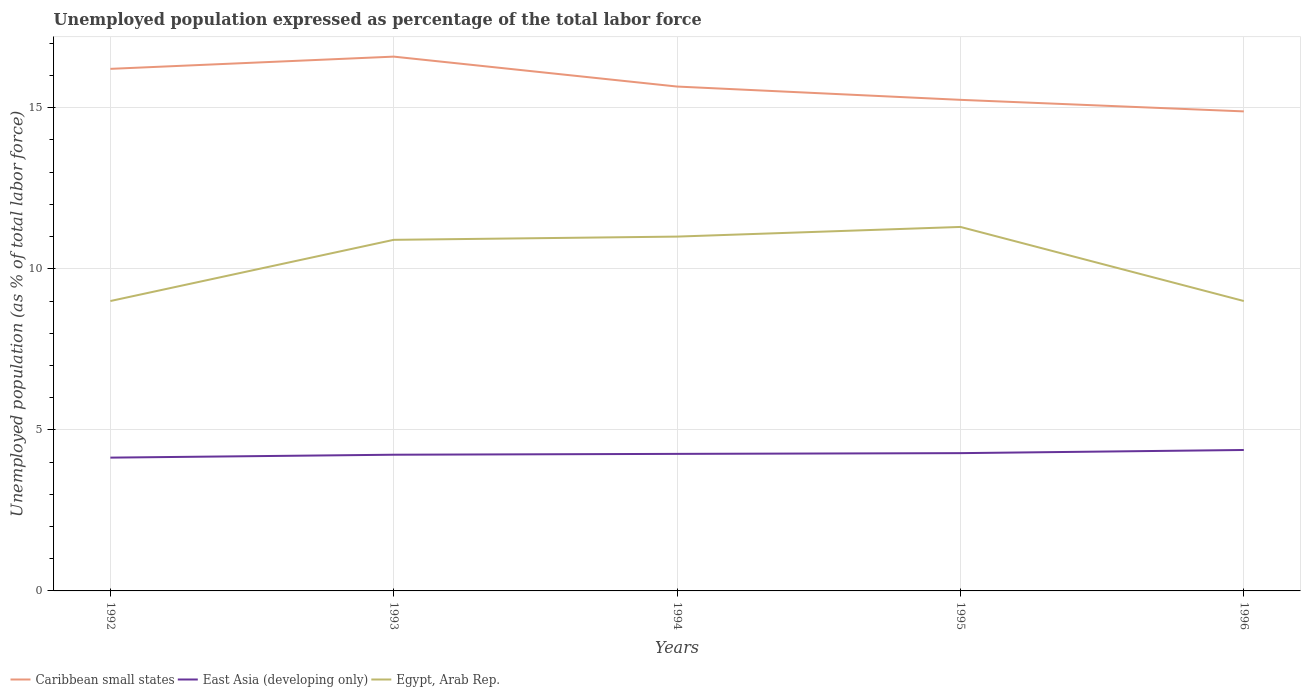Does the line corresponding to Egypt, Arab Rep. intersect with the line corresponding to East Asia (developing only)?
Your response must be concise. No. Across all years, what is the maximum unemployment in in Caribbean small states?
Offer a very short reply. 14.89. What is the difference between the highest and the second highest unemployment in in Egypt, Arab Rep.?
Your answer should be very brief. 2.3. What is the difference between the highest and the lowest unemployment in in Caribbean small states?
Provide a short and direct response. 2. Is the unemployment in in Egypt, Arab Rep. strictly greater than the unemployment in in Caribbean small states over the years?
Your answer should be compact. Yes. How many lines are there?
Offer a very short reply. 3. What is the difference between two consecutive major ticks on the Y-axis?
Make the answer very short. 5. Are the values on the major ticks of Y-axis written in scientific E-notation?
Keep it short and to the point. No. Does the graph contain any zero values?
Provide a succinct answer. No. Does the graph contain grids?
Give a very brief answer. Yes. How are the legend labels stacked?
Offer a terse response. Horizontal. What is the title of the graph?
Provide a short and direct response. Unemployed population expressed as percentage of the total labor force. What is the label or title of the Y-axis?
Offer a terse response. Unemployed population (as % of total labor force). What is the Unemployed population (as % of total labor force) in Caribbean small states in 1992?
Offer a very short reply. 16.21. What is the Unemployed population (as % of total labor force) of East Asia (developing only) in 1992?
Your answer should be compact. 4.14. What is the Unemployed population (as % of total labor force) of Caribbean small states in 1993?
Your response must be concise. 16.59. What is the Unemployed population (as % of total labor force) in East Asia (developing only) in 1993?
Offer a very short reply. 4.23. What is the Unemployed population (as % of total labor force) in Egypt, Arab Rep. in 1993?
Provide a succinct answer. 10.9. What is the Unemployed population (as % of total labor force) of Caribbean small states in 1994?
Make the answer very short. 15.66. What is the Unemployed population (as % of total labor force) in East Asia (developing only) in 1994?
Keep it short and to the point. 4.25. What is the Unemployed population (as % of total labor force) in Caribbean small states in 1995?
Offer a very short reply. 15.25. What is the Unemployed population (as % of total labor force) in East Asia (developing only) in 1995?
Provide a succinct answer. 4.28. What is the Unemployed population (as % of total labor force) of Egypt, Arab Rep. in 1995?
Ensure brevity in your answer.  11.3. What is the Unemployed population (as % of total labor force) in Caribbean small states in 1996?
Your response must be concise. 14.89. What is the Unemployed population (as % of total labor force) in East Asia (developing only) in 1996?
Provide a short and direct response. 4.38. Across all years, what is the maximum Unemployed population (as % of total labor force) of Caribbean small states?
Offer a very short reply. 16.59. Across all years, what is the maximum Unemployed population (as % of total labor force) in East Asia (developing only)?
Offer a very short reply. 4.38. Across all years, what is the maximum Unemployed population (as % of total labor force) in Egypt, Arab Rep.?
Your response must be concise. 11.3. Across all years, what is the minimum Unemployed population (as % of total labor force) in Caribbean small states?
Offer a terse response. 14.89. Across all years, what is the minimum Unemployed population (as % of total labor force) in East Asia (developing only)?
Provide a succinct answer. 4.14. Across all years, what is the minimum Unemployed population (as % of total labor force) in Egypt, Arab Rep.?
Make the answer very short. 9. What is the total Unemployed population (as % of total labor force) in Caribbean small states in the graph?
Offer a very short reply. 78.59. What is the total Unemployed population (as % of total labor force) of East Asia (developing only) in the graph?
Keep it short and to the point. 21.27. What is the total Unemployed population (as % of total labor force) of Egypt, Arab Rep. in the graph?
Provide a succinct answer. 51.2. What is the difference between the Unemployed population (as % of total labor force) in Caribbean small states in 1992 and that in 1993?
Offer a terse response. -0.38. What is the difference between the Unemployed population (as % of total labor force) of East Asia (developing only) in 1992 and that in 1993?
Your response must be concise. -0.09. What is the difference between the Unemployed population (as % of total labor force) of Egypt, Arab Rep. in 1992 and that in 1993?
Your answer should be compact. -1.9. What is the difference between the Unemployed population (as % of total labor force) of Caribbean small states in 1992 and that in 1994?
Your response must be concise. 0.55. What is the difference between the Unemployed population (as % of total labor force) of East Asia (developing only) in 1992 and that in 1994?
Provide a succinct answer. -0.12. What is the difference between the Unemployed population (as % of total labor force) of Egypt, Arab Rep. in 1992 and that in 1994?
Give a very brief answer. -2. What is the difference between the Unemployed population (as % of total labor force) in Caribbean small states in 1992 and that in 1995?
Your answer should be very brief. 0.96. What is the difference between the Unemployed population (as % of total labor force) in East Asia (developing only) in 1992 and that in 1995?
Give a very brief answer. -0.14. What is the difference between the Unemployed population (as % of total labor force) in Egypt, Arab Rep. in 1992 and that in 1995?
Keep it short and to the point. -2.3. What is the difference between the Unemployed population (as % of total labor force) of Caribbean small states in 1992 and that in 1996?
Make the answer very short. 1.32. What is the difference between the Unemployed population (as % of total labor force) in East Asia (developing only) in 1992 and that in 1996?
Offer a very short reply. -0.24. What is the difference between the Unemployed population (as % of total labor force) of Egypt, Arab Rep. in 1992 and that in 1996?
Your answer should be very brief. 0. What is the difference between the Unemployed population (as % of total labor force) of Caribbean small states in 1993 and that in 1994?
Your answer should be very brief. 0.93. What is the difference between the Unemployed population (as % of total labor force) in East Asia (developing only) in 1993 and that in 1994?
Your answer should be very brief. -0.03. What is the difference between the Unemployed population (as % of total labor force) of Egypt, Arab Rep. in 1993 and that in 1994?
Your answer should be compact. -0.1. What is the difference between the Unemployed population (as % of total labor force) of Caribbean small states in 1993 and that in 1995?
Ensure brevity in your answer.  1.34. What is the difference between the Unemployed population (as % of total labor force) in East Asia (developing only) in 1993 and that in 1995?
Provide a short and direct response. -0.05. What is the difference between the Unemployed population (as % of total labor force) of Egypt, Arab Rep. in 1993 and that in 1995?
Provide a short and direct response. -0.4. What is the difference between the Unemployed population (as % of total labor force) in Caribbean small states in 1993 and that in 1996?
Make the answer very short. 1.7. What is the difference between the Unemployed population (as % of total labor force) of East Asia (developing only) in 1993 and that in 1996?
Provide a succinct answer. -0.15. What is the difference between the Unemployed population (as % of total labor force) of Egypt, Arab Rep. in 1993 and that in 1996?
Your response must be concise. 1.9. What is the difference between the Unemployed population (as % of total labor force) in Caribbean small states in 1994 and that in 1995?
Offer a very short reply. 0.41. What is the difference between the Unemployed population (as % of total labor force) of East Asia (developing only) in 1994 and that in 1995?
Provide a succinct answer. -0.02. What is the difference between the Unemployed population (as % of total labor force) in Egypt, Arab Rep. in 1994 and that in 1995?
Offer a terse response. -0.3. What is the difference between the Unemployed population (as % of total labor force) of Caribbean small states in 1994 and that in 1996?
Offer a terse response. 0.77. What is the difference between the Unemployed population (as % of total labor force) of East Asia (developing only) in 1994 and that in 1996?
Give a very brief answer. -0.12. What is the difference between the Unemployed population (as % of total labor force) in Caribbean small states in 1995 and that in 1996?
Ensure brevity in your answer.  0.36. What is the difference between the Unemployed population (as % of total labor force) in East Asia (developing only) in 1995 and that in 1996?
Offer a terse response. -0.1. What is the difference between the Unemployed population (as % of total labor force) in Caribbean small states in 1992 and the Unemployed population (as % of total labor force) in East Asia (developing only) in 1993?
Your answer should be compact. 11.98. What is the difference between the Unemployed population (as % of total labor force) in Caribbean small states in 1992 and the Unemployed population (as % of total labor force) in Egypt, Arab Rep. in 1993?
Ensure brevity in your answer.  5.31. What is the difference between the Unemployed population (as % of total labor force) in East Asia (developing only) in 1992 and the Unemployed population (as % of total labor force) in Egypt, Arab Rep. in 1993?
Your response must be concise. -6.76. What is the difference between the Unemployed population (as % of total labor force) of Caribbean small states in 1992 and the Unemployed population (as % of total labor force) of East Asia (developing only) in 1994?
Provide a succinct answer. 11.95. What is the difference between the Unemployed population (as % of total labor force) of Caribbean small states in 1992 and the Unemployed population (as % of total labor force) of Egypt, Arab Rep. in 1994?
Offer a terse response. 5.21. What is the difference between the Unemployed population (as % of total labor force) in East Asia (developing only) in 1992 and the Unemployed population (as % of total labor force) in Egypt, Arab Rep. in 1994?
Your answer should be very brief. -6.86. What is the difference between the Unemployed population (as % of total labor force) of Caribbean small states in 1992 and the Unemployed population (as % of total labor force) of East Asia (developing only) in 1995?
Provide a succinct answer. 11.93. What is the difference between the Unemployed population (as % of total labor force) in Caribbean small states in 1992 and the Unemployed population (as % of total labor force) in Egypt, Arab Rep. in 1995?
Offer a very short reply. 4.91. What is the difference between the Unemployed population (as % of total labor force) in East Asia (developing only) in 1992 and the Unemployed population (as % of total labor force) in Egypt, Arab Rep. in 1995?
Your response must be concise. -7.16. What is the difference between the Unemployed population (as % of total labor force) in Caribbean small states in 1992 and the Unemployed population (as % of total labor force) in East Asia (developing only) in 1996?
Offer a very short reply. 11.83. What is the difference between the Unemployed population (as % of total labor force) in Caribbean small states in 1992 and the Unemployed population (as % of total labor force) in Egypt, Arab Rep. in 1996?
Ensure brevity in your answer.  7.21. What is the difference between the Unemployed population (as % of total labor force) of East Asia (developing only) in 1992 and the Unemployed population (as % of total labor force) of Egypt, Arab Rep. in 1996?
Your response must be concise. -4.86. What is the difference between the Unemployed population (as % of total labor force) of Caribbean small states in 1993 and the Unemployed population (as % of total labor force) of East Asia (developing only) in 1994?
Your response must be concise. 12.33. What is the difference between the Unemployed population (as % of total labor force) of Caribbean small states in 1993 and the Unemployed population (as % of total labor force) of Egypt, Arab Rep. in 1994?
Offer a terse response. 5.59. What is the difference between the Unemployed population (as % of total labor force) in East Asia (developing only) in 1993 and the Unemployed population (as % of total labor force) in Egypt, Arab Rep. in 1994?
Provide a short and direct response. -6.77. What is the difference between the Unemployed population (as % of total labor force) of Caribbean small states in 1993 and the Unemployed population (as % of total labor force) of East Asia (developing only) in 1995?
Keep it short and to the point. 12.31. What is the difference between the Unemployed population (as % of total labor force) in Caribbean small states in 1993 and the Unemployed population (as % of total labor force) in Egypt, Arab Rep. in 1995?
Provide a succinct answer. 5.29. What is the difference between the Unemployed population (as % of total labor force) of East Asia (developing only) in 1993 and the Unemployed population (as % of total labor force) of Egypt, Arab Rep. in 1995?
Your answer should be very brief. -7.07. What is the difference between the Unemployed population (as % of total labor force) of Caribbean small states in 1993 and the Unemployed population (as % of total labor force) of East Asia (developing only) in 1996?
Provide a succinct answer. 12.21. What is the difference between the Unemployed population (as % of total labor force) in Caribbean small states in 1993 and the Unemployed population (as % of total labor force) in Egypt, Arab Rep. in 1996?
Provide a short and direct response. 7.59. What is the difference between the Unemployed population (as % of total labor force) of East Asia (developing only) in 1993 and the Unemployed population (as % of total labor force) of Egypt, Arab Rep. in 1996?
Give a very brief answer. -4.77. What is the difference between the Unemployed population (as % of total labor force) of Caribbean small states in 1994 and the Unemployed population (as % of total labor force) of East Asia (developing only) in 1995?
Provide a succinct answer. 11.38. What is the difference between the Unemployed population (as % of total labor force) of Caribbean small states in 1994 and the Unemployed population (as % of total labor force) of Egypt, Arab Rep. in 1995?
Ensure brevity in your answer.  4.36. What is the difference between the Unemployed population (as % of total labor force) of East Asia (developing only) in 1994 and the Unemployed population (as % of total labor force) of Egypt, Arab Rep. in 1995?
Keep it short and to the point. -7.05. What is the difference between the Unemployed population (as % of total labor force) in Caribbean small states in 1994 and the Unemployed population (as % of total labor force) in East Asia (developing only) in 1996?
Provide a short and direct response. 11.28. What is the difference between the Unemployed population (as % of total labor force) in Caribbean small states in 1994 and the Unemployed population (as % of total labor force) in Egypt, Arab Rep. in 1996?
Your response must be concise. 6.66. What is the difference between the Unemployed population (as % of total labor force) of East Asia (developing only) in 1994 and the Unemployed population (as % of total labor force) of Egypt, Arab Rep. in 1996?
Give a very brief answer. -4.75. What is the difference between the Unemployed population (as % of total labor force) of Caribbean small states in 1995 and the Unemployed population (as % of total labor force) of East Asia (developing only) in 1996?
Give a very brief answer. 10.87. What is the difference between the Unemployed population (as % of total labor force) of Caribbean small states in 1995 and the Unemployed population (as % of total labor force) of Egypt, Arab Rep. in 1996?
Offer a very short reply. 6.25. What is the difference between the Unemployed population (as % of total labor force) of East Asia (developing only) in 1995 and the Unemployed population (as % of total labor force) of Egypt, Arab Rep. in 1996?
Give a very brief answer. -4.72. What is the average Unemployed population (as % of total labor force) of Caribbean small states per year?
Your answer should be compact. 15.72. What is the average Unemployed population (as % of total labor force) of East Asia (developing only) per year?
Offer a terse response. 4.25. What is the average Unemployed population (as % of total labor force) in Egypt, Arab Rep. per year?
Offer a terse response. 10.24. In the year 1992, what is the difference between the Unemployed population (as % of total labor force) in Caribbean small states and Unemployed population (as % of total labor force) in East Asia (developing only)?
Ensure brevity in your answer.  12.07. In the year 1992, what is the difference between the Unemployed population (as % of total labor force) in Caribbean small states and Unemployed population (as % of total labor force) in Egypt, Arab Rep.?
Your answer should be compact. 7.21. In the year 1992, what is the difference between the Unemployed population (as % of total labor force) in East Asia (developing only) and Unemployed population (as % of total labor force) in Egypt, Arab Rep.?
Provide a short and direct response. -4.86. In the year 1993, what is the difference between the Unemployed population (as % of total labor force) of Caribbean small states and Unemployed population (as % of total labor force) of East Asia (developing only)?
Keep it short and to the point. 12.36. In the year 1993, what is the difference between the Unemployed population (as % of total labor force) in Caribbean small states and Unemployed population (as % of total labor force) in Egypt, Arab Rep.?
Provide a short and direct response. 5.69. In the year 1993, what is the difference between the Unemployed population (as % of total labor force) of East Asia (developing only) and Unemployed population (as % of total labor force) of Egypt, Arab Rep.?
Provide a short and direct response. -6.67. In the year 1994, what is the difference between the Unemployed population (as % of total labor force) of Caribbean small states and Unemployed population (as % of total labor force) of East Asia (developing only)?
Offer a terse response. 11.4. In the year 1994, what is the difference between the Unemployed population (as % of total labor force) in Caribbean small states and Unemployed population (as % of total labor force) in Egypt, Arab Rep.?
Offer a very short reply. 4.66. In the year 1994, what is the difference between the Unemployed population (as % of total labor force) of East Asia (developing only) and Unemployed population (as % of total labor force) of Egypt, Arab Rep.?
Your response must be concise. -6.75. In the year 1995, what is the difference between the Unemployed population (as % of total labor force) in Caribbean small states and Unemployed population (as % of total labor force) in East Asia (developing only)?
Your answer should be compact. 10.97. In the year 1995, what is the difference between the Unemployed population (as % of total labor force) of Caribbean small states and Unemployed population (as % of total labor force) of Egypt, Arab Rep.?
Your answer should be very brief. 3.95. In the year 1995, what is the difference between the Unemployed population (as % of total labor force) of East Asia (developing only) and Unemployed population (as % of total labor force) of Egypt, Arab Rep.?
Your answer should be compact. -7.02. In the year 1996, what is the difference between the Unemployed population (as % of total labor force) of Caribbean small states and Unemployed population (as % of total labor force) of East Asia (developing only)?
Keep it short and to the point. 10.51. In the year 1996, what is the difference between the Unemployed population (as % of total labor force) in Caribbean small states and Unemployed population (as % of total labor force) in Egypt, Arab Rep.?
Your response must be concise. 5.89. In the year 1996, what is the difference between the Unemployed population (as % of total labor force) in East Asia (developing only) and Unemployed population (as % of total labor force) in Egypt, Arab Rep.?
Ensure brevity in your answer.  -4.62. What is the ratio of the Unemployed population (as % of total labor force) of Caribbean small states in 1992 to that in 1993?
Offer a terse response. 0.98. What is the ratio of the Unemployed population (as % of total labor force) of East Asia (developing only) in 1992 to that in 1993?
Provide a succinct answer. 0.98. What is the ratio of the Unemployed population (as % of total labor force) in Egypt, Arab Rep. in 1992 to that in 1993?
Your answer should be compact. 0.83. What is the ratio of the Unemployed population (as % of total labor force) of Caribbean small states in 1992 to that in 1994?
Make the answer very short. 1.04. What is the ratio of the Unemployed population (as % of total labor force) of East Asia (developing only) in 1992 to that in 1994?
Ensure brevity in your answer.  0.97. What is the ratio of the Unemployed population (as % of total labor force) in Egypt, Arab Rep. in 1992 to that in 1994?
Offer a terse response. 0.82. What is the ratio of the Unemployed population (as % of total labor force) in Caribbean small states in 1992 to that in 1995?
Give a very brief answer. 1.06. What is the ratio of the Unemployed population (as % of total labor force) of East Asia (developing only) in 1992 to that in 1995?
Give a very brief answer. 0.97. What is the ratio of the Unemployed population (as % of total labor force) in Egypt, Arab Rep. in 1992 to that in 1995?
Offer a terse response. 0.8. What is the ratio of the Unemployed population (as % of total labor force) in Caribbean small states in 1992 to that in 1996?
Make the answer very short. 1.09. What is the ratio of the Unemployed population (as % of total labor force) of East Asia (developing only) in 1992 to that in 1996?
Your answer should be very brief. 0.95. What is the ratio of the Unemployed population (as % of total labor force) in Caribbean small states in 1993 to that in 1994?
Your response must be concise. 1.06. What is the ratio of the Unemployed population (as % of total labor force) of Egypt, Arab Rep. in 1993 to that in 1994?
Offer a terse response. 0.99. What is the ratio of the Unemployed population (as % of total labor force) of Caribbean small states in 1993 to that in 1995?
Make the answer very short. 1.09. What is the ratio of the Unemployed population (as % of total labor force) of Egypt, Arab Rep. in 1993 to that in 1995?
Provide a short and direct response. 0.96. What is the ratio of the Unemployed population (as % of total labor force) in Caribbean small states in 1993 to that in 1996?
Ensure brevity in your answer.  1.11. What is the ratio of the Unemployed population (as % of total labor force) of East Asia (developing only) in 1993 to that in 1996?
Your answer should be compact. 0.97. What is the ratio of the Unemployed population (as % of total labor force) in Egypt, Arab Rep. in 1993 to that in 1996?
Give a very brief answer. 1.21. What is the ratio of the Unemployed population (as % of total labor force) of Caribbean small states in 1994 to that in 1995?
Your answer should be compact. 1.03. What is the ratio of the Unemployed population (as % of total labor force) in East Asia (developing only) in 1994 to that in 1995?
Your answer should be very brief. 0.99. What is the ratio of the Unemployed population (as % of total labor force) in Egypt, Arab Rep. in 1994 to that in 1995?
Keep it short and to the point. 0.97. What is the ratio of the Unemployed population (as % of total labor force) of Caribbean small states in 1994 to that in 1996?
Provide a short and direct response. 1.05. What is the ratio of the Unemployed population (as % of total labor force) of East Asia (developing only) in 1994 to that in 1996?
Offer a terse response. 0.97. What is the ratio of the Unemployed population (as % of total labor force) in Egypt, Arab Rep. in 1994 to that in 1996?
Give a very brief answer. 1.22. What is the ratio of the Unemployed population (as % of total labor force) in Caribbean small states in 1995 to that in 1996?
Provide a succinct answer. 1.02. What is the ratio of the Unemployed population (as % of total labor force) in East Asia (developing only) in 1995 to that in 1996?
Offer a terse response. 0.98. What is the ratio of the Unemployed population (as % of total labor force) in Egypt, Arab Rep. in 1995 to that in 1996?
Provide a short and direct response. 1.26. What is the difference between the highest and the second highest Unemployed population (as % of total labor force) in Caribbean small states?
Give a very brief answer. 0.38. What is the difference between the highest and the second highest Unemployed population (as % of total labor force) in East Asia (developing only)?
Your answer should be compact. 0.1. What is the difference between the highest and the second highest Unemployed population (as % of total labor force) in Egypt, Arab Rep.?
Give a very brief answer. 0.3. What is the difference between the highest and the lowest Unemployed population (as % of total labor force) in Caribbean small states?
Ensure brevity in your answer.  1.7. What is the difference between the highest and the lowest Unemployed population (as % of total labor force) in East Asia (developing only)?
Make the answer very short. 0.24. What is the difference between the highest and the lowest Unemployed population (as % of total labor force) of Egypt, Arab Rep.?
Ensure brevity in your answer.  2.3. 